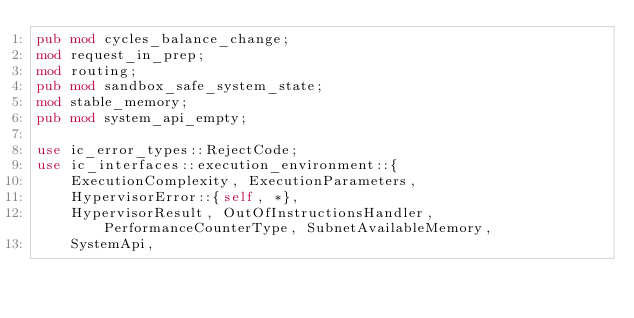<code> <loc_0><loc_0><loc_500><loc_500><_Rust_>pub mod cycles_balance_change;
mod request_in_prep;
mod routing;
pub mod sandbox_safe_system_state;
mod stable_memory;
pub mod system_api_empty;

use ic_error_types::RejectCode;
use ic_interfaces::execution_environment::{
    ExecutionComplexity, ExecutionParameters,
    HypervisorError::{self, *},
    HypervisorResult, OutOfInstructionsHandler, PerformanceCounterType, SubnetAvailableMemory,
    SystemApi,</code> 